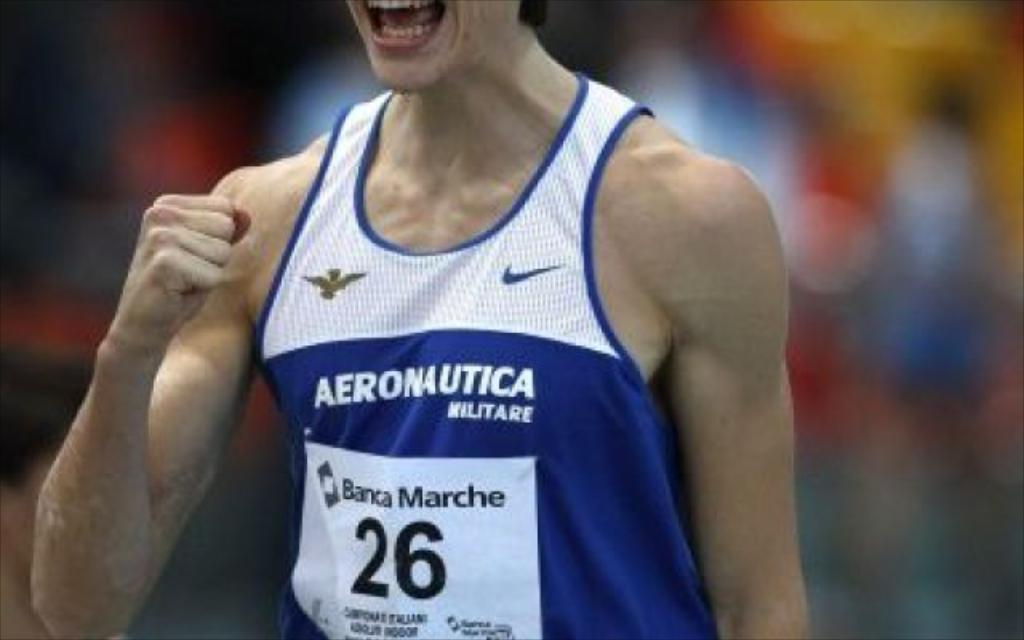What is the main subject of the image? There is a person standing in the center of the image. What is the person wearing in the image? The person is wearing a blue and white color t-shirt. What type of party is being held in the image? There is no party present in the image; it only features a person wearing a blue and white t-shirt. How many times has the person exchanged their t-shirt in the image? There is no indication of the person exchanging their t-shirt in the image; they are wearing a single blue and white t-shirt. 